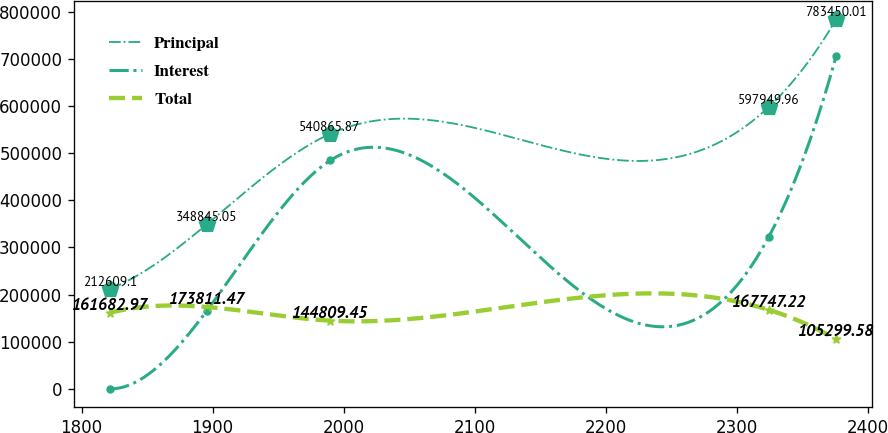Convert chart. <chart><loc_0><loc_0><loc_500><loc_500><line_chart><ecel><fcel>Principal<fcel>Interest<fcel>Total<nl><fcel>1821.9<fcel>212609<fcel>194.95<fcel>161683<nl><fcel>1895.47<fcel>348845<fcel>165392<fcel>173811<nl><fcel>1989.67<fcel>540866<fcel>484421<fcel>144809<nl><fcel>2324.16<fcel>597950<fcel>322602<fcel>167747<nl><fcel>2375.51<fcel>783450<fcel>705615<fcel>105300<nl></chart> 